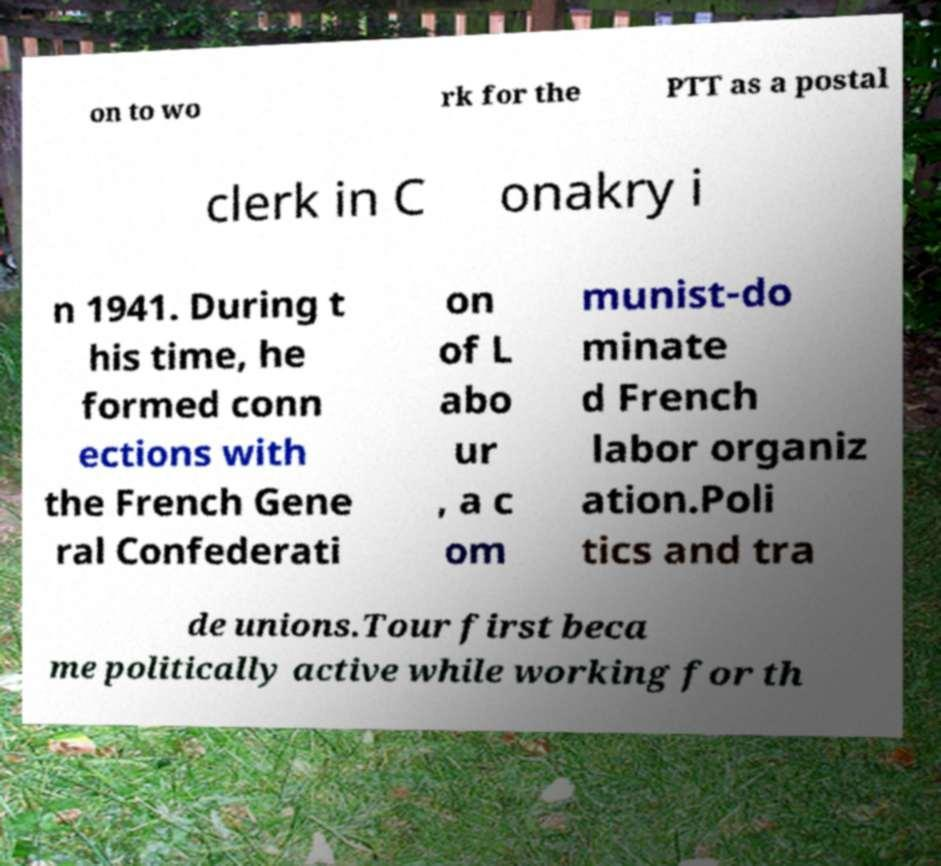Please read and relay the text visible in this image. What does it say? on to wo rk for the PTT as a postal clerk in C onakry i n 1941. During t his time, he formed conn ections with the French Gene ral Confederati on of L abo ur , a c om munist-do minate d French labor organiz ation.Poli tics and tra de unions.Tour first beca me politically active while working for th 